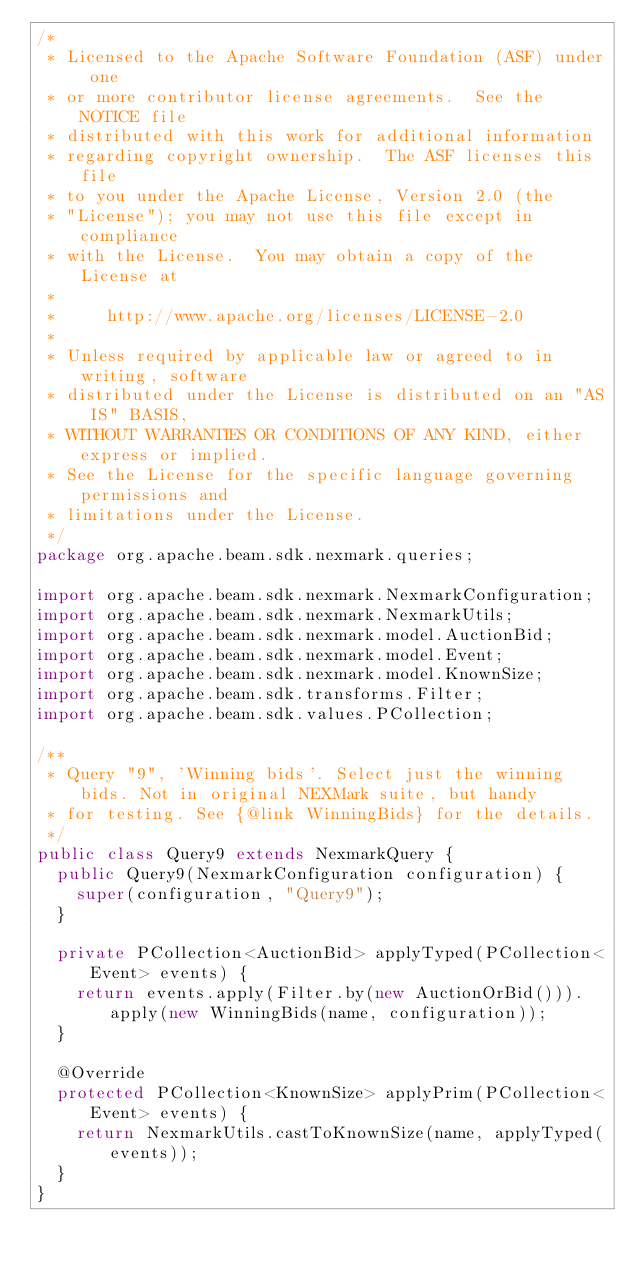Convert code to text. <code><loc_0><loc_0><loc_500><loc_500><_Java_>/*
 * Licensed to the Apache Software Foundation (ASF) under one
 * or more contributor license agreements.  See the NOTICE file
 * distributed with this work for additional information
 * regarding copyright ownership.  The ASF licenses this file
 * to you under the Apache License, Version 2.0 (the
 * "License"); you may not use this file except in compliance
 * with the License.  You may obtain a copy of the License at
 *
 *     http://www.apache.org/licenses/LICENSE-2.0
 *
 * Unless required by applicable law or agreed to in writing, software
 * distributed under the License is distributed on an "AS IS" BASIS,
 * WITHOUT WARRANTIES OR CONDITIONS OF ANY KIND, either express or implied.
 * See the License for the specific language governing permissions and
 * limitations under the License.
 */
package org.apache.beam.sdk.nexmark.queries;

import org.apache.beam.sdk.nexmark.NexmarkConfiguration;
import org.apache.beam.sdk.nexmark.NexmarkUtils;
import org.apache.beam.sdk.nexmark.model.AuctionBid;
import org.apache.beam.sdk.nexmark.model.Event;
import org.apache.beam.sdk.nexmark.model.KnownSize;
import org.apache.beam.sdk.transforms.Filter;
import org.apache.beam.sdk.values.PCollection;

/**
 * Query "9", 'Winning bids'. Select just the winning bids. Not in original NEXMark suite, but handy
 * for testing. See {@link WinningBids} for the details.
 */
public class Query9 extends NexmarkQuery {
  public Query9(NexmarkConfiguration configuration) {
    super(configuration, "Query9");
  }

  private PCollection<AuctionBid> applyTyped(PCollection<Event> events) {
    return events.apply(Filter.by(new AuctionOrBid())).apply(new WinningBids(name, configuration));
  }

  @Override
  protected PCollection<KnownSize> applyPrim(PCollection<Event> events) {
    return NexmarkUtils.castToKnownSize(name, applyTyped(events));
  }
}
</code> 